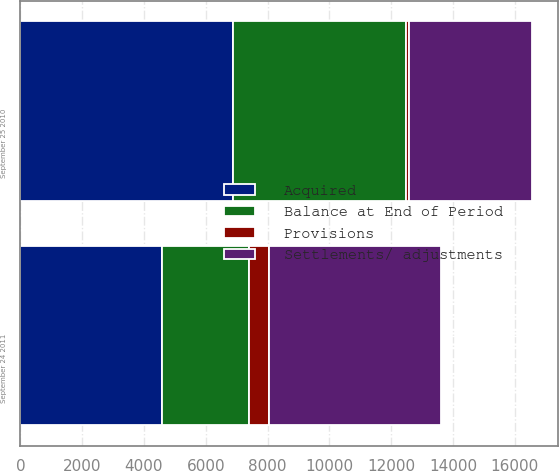<chart> <loc_0><loc_0><loc_500><loc_500><stacked_bar_chart><ecel><fcel>September 24 2011<fcel>September 25 2010<nl><fcel>Balance at End of Period<fcel>2830<fcel>5602<nl><fcel>Settlements/ adjustments<fcel>5535<fcel>3994<nl><fcel>Provisions<fcel>657<fcel>99<nl><fcel>Acquired<fcel>4574<fcel>6865<nl></chart> 